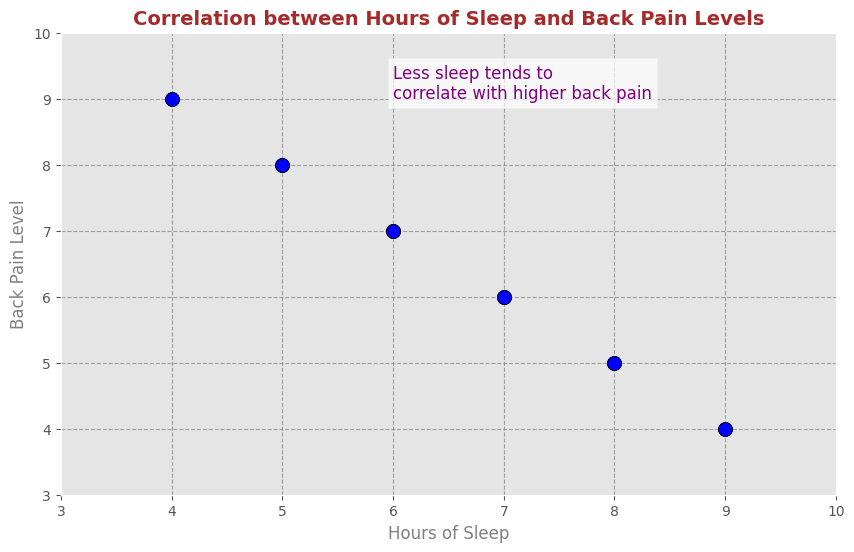What is the general trend between hours of sleep and back pain level? To determine the trend, look at the overall pattern of the scatter plot dots. As the hours of sleep increase from left to right along the x-axis, the reported back pain levels (y-axis) tend to decrease, indicating a negative correlation.
Answer: Negative correlation Which data points indicate the highest level of back pain? Identify the data points that have the highest back pain level on the y-axis. The highest back pain level observed is 9, which corresponds to 4 hours of sleep.
Answer: (4, 9) Among people who sleep 7 hours, what is the most frequent back pain level? Extract the y-values for the x-value of 7 hours. The back pain level for 7 hours of sleep frequently appears as 6.
Answer: 6 Are there any data points where back pain levels remain constant despite different hours of sleep? Check the y-values across different x-values for consistency. The back pain level of 6 appears consistently for both 7 hours and other sleep durations like 6 and 5 hours.
Answer: Yes, back pain level of 6 Do people who sleep 9 hours have higher or lower back pain levels compared to those who sleep 6 hours? Compare back pain levels for 9 hours and 6 hours of sleep. For 9 hours, the back pain level tends to be around 4, while for 6 hours, it is around 7. Therefore, people who sleep 9 hours have lower back pain levels.
Answer: Lower What does the text annotation in the plot suggest? Read and interpret the text annotation. It states "Less sleep tends to correlate with higher back pain," implying that a decrease in sleep hours generally leads to an increase in back pain levels.
Answer: Less sleep leads to higher back pain Calculate the difference in back pain level between the maximum and minimum hours of sleep recorded. The maximum sleep recorded is 9 hours with a back pain level of 4, and the minimum is 4 hours with a back pain level of 9. The difference in back pain level is 9 - 4 = 5.
Answer: 5 Which sleep duration has no back pain levels above 6? Examine the data points for back pain levels across different sleep durations. For 8 hours of sleep, all back pain levels observed are 5, which are below 6.
Answer: 8 hours How do the grid lines help in interpreting the scatter plot? Explain how the grid lines aid in understanding the data. The grid lines help by providing a reference to easily locate the specific values for hours of sleep and back pain levels, making it clearer to identify patterns and relationships.
Answer: Provide reference for values For sleep durations of 5 and 8 hours, how do the back pain levels compare? Extract the back pain levels for 5 and 8 hours of sleep. For 5 hours, the back pain level is around 8; for 8 hours, it is around 5. Therefore, 5 hours of sleep has higher back pain levels compared to 8 hours.
Answer: 5 hours have higher back pain compared to 8 hours 